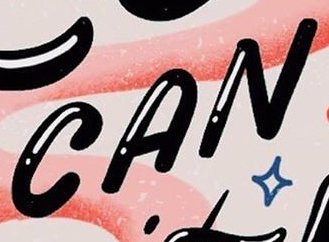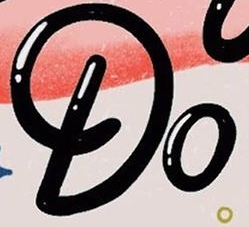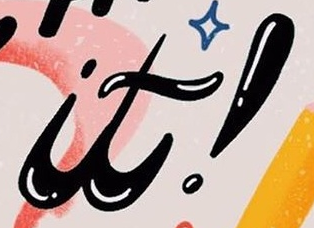Read the text content from these images in order, separated by a semicolon. CAN; Do; it! 